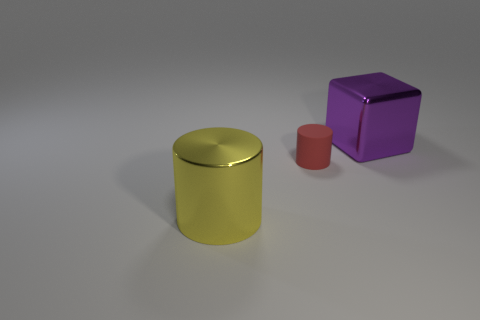Add 2 large red blocks. How many objects exist? 5 Subtract all cylinders. How many objects are left? 1 Subtract 1 cubes. How many cubes are left? 0 Add 3 tiny red cylinders. How many tiny red cylinders are left? 4 Add 2 shiny things. How many shiny things exist? 4 Subtract 0 cyan cubes. How many objects are left? 3 Subtract all red blocks. Subtract all green balls. How many blocks are left? 1 Subtract all purple cubes. How many yellow cylinders are left? 1 Subtract all small cyan rubber balls. Subtract all metallic objects. How many objects are left? 1 